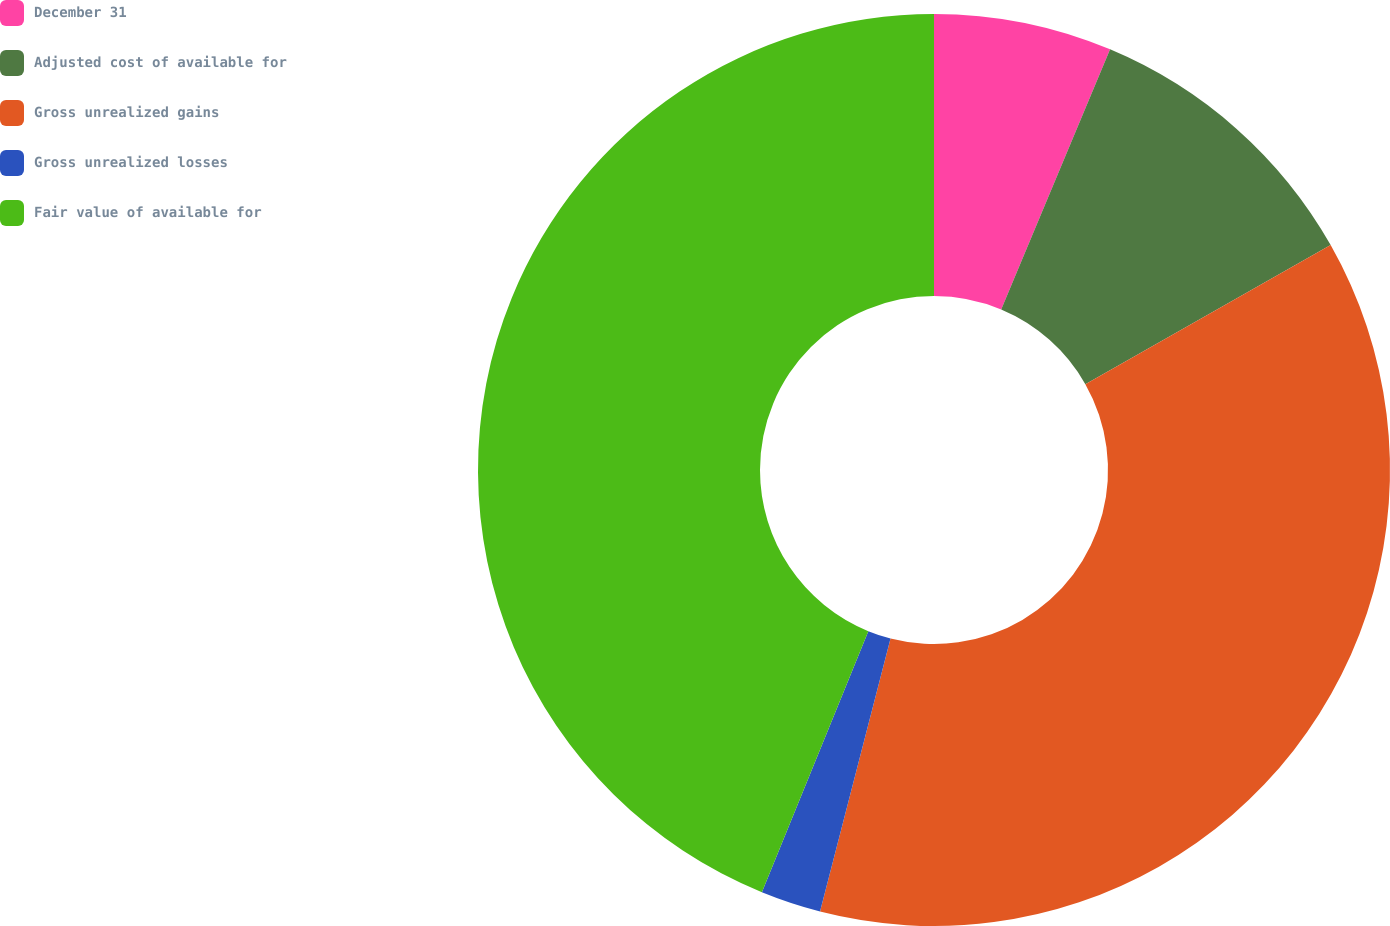Convert chart to OTSL. <chart><loc_0><loc_0><loc_500><loc_500><pie_chart><fcel>December 31<fcel>Adjusted cost of available for<fcel>Gross unrealized gains<fcel>Gross unrealized losses<fcel>Fair value of available for<nl><fcel>6.31%<fcel>10.48%<fcel>37.23%<fcel>2.14%<fcel>43.84%<nl></chart> 